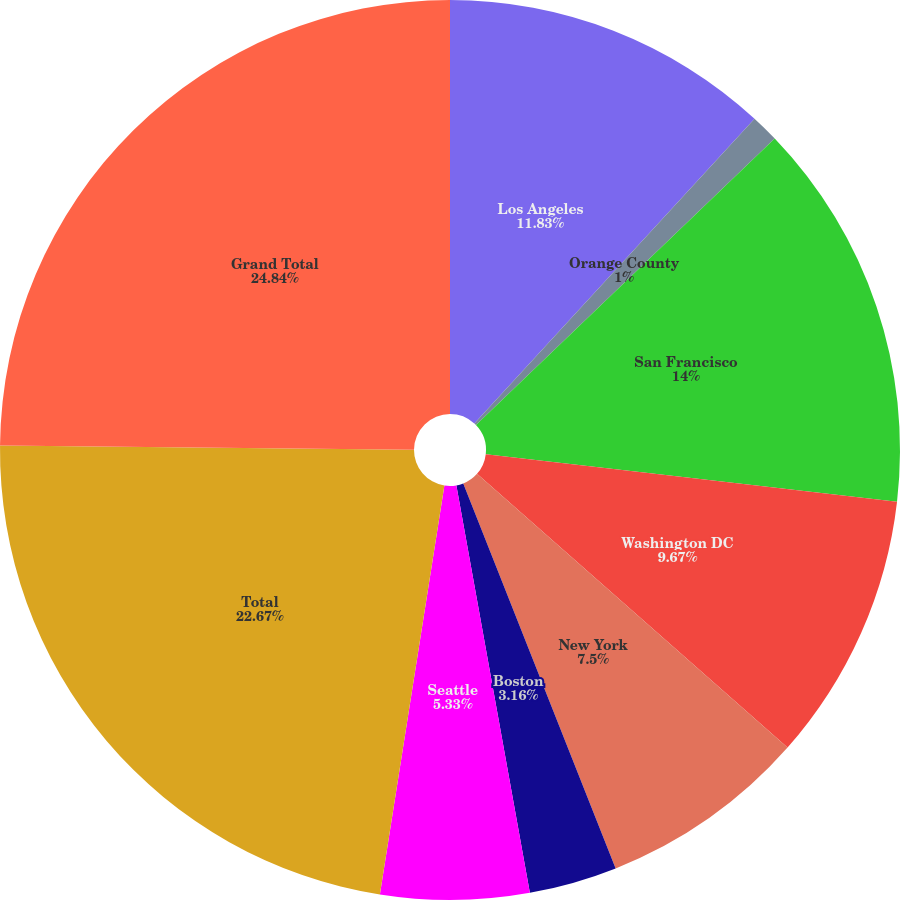Convert chart to OTSL. <chart><loc_0><loc_0><loc_500><loc_500><pie_chart><fcel>Los Angeles<fcel>Orange County<fcel>San Francisco<fcel>Washington DC<fcel>New York<fcel>Boston<fcel>Seattle<fcel>Total<fcel>Grand Total<nl><fcel>11.83%<fcel>1.0%<fcel>14.0%<fcel>9.67%<fcel>7.5%<fcel>3.16%<fcel>5.33%<fcel>22.67%<fcel>24.84%<nl></chart> 